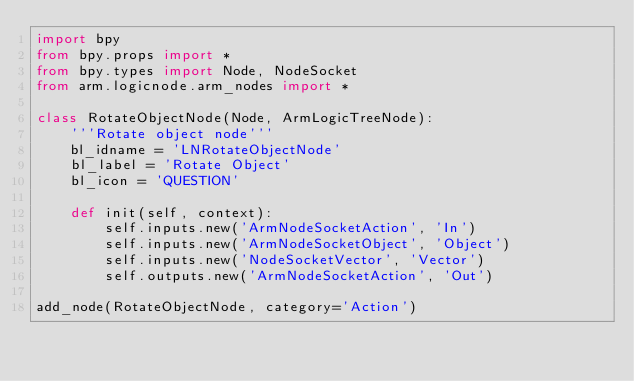Convert code to text. <code><loc_0><loc_0><loc_500><loc_500><_Python_>import bpy
from bpy.props import *
from bpy.types import Node, NodeSocket
from arm.logicnode.arm_nodes import *

class RotateObjectNode(Node, ArmLogicTreeNode):
    '''Rotate object node'''
    bl_idname = 'LNRotateObjectNode'
    bl_label = 'Rotate Object'
    bl_icon = 'QUESTION'

    def init(self, context):
        self.inputs.new('ArmNodeSocketAction', 'In')
        self.inputs.new('ArmNodeSocketObject', 'Object')
        self.inputs.new('NodeSocketVector', 'Vector')
        self.outputs.new('ArmNodeSocketAction', 'Out')

add_node(RotateObjectNode, category='Action')
</code> 